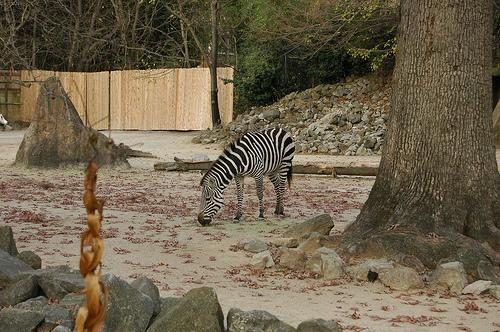Give a description of the plant leaf in the image. It is a brown dried plant leaf. Comment on the state of the trees in the photo. There are leafy trees, a tree with no leaves, and a large textured tree trunk. What is the zebra's interaction with the dried leaves in the image? The zebra is eating the dried leaves. How could one describe the reed in the scene? A light brown curled plant reed. What is the most noticeable feature of the zebra's tail and mane hair? The most noticeable feature is that they are both black in color. Point out an object that is fallen on the ground in the image. A tree log is fallen on the ground. Enumerate the number of rocks in the image and describe them. There are multiple rocks, including grey rocks in a pile, pointy triangular-shaped rock, and rocks in front of a tree. What is the predominant color of the fence panels in the image? The predominant color of the fence panels is brown. Describe the location of a slim tree in relation to the fence. The slim tree is positioned in front of the fence. Identify the main animal in the image and its action. The primary animal is a black and white zebra, which is eating something on the ground. Is the large rock in the image floating in the sky? The rocks are described as being on the ground or in piles, so mentioning a floating rock is misleading. Do you notice a river flowing through the image? There is no mention of a river or any water source in the image, making this instruction misleading. Are there any bright pink leaves scattered on the ground? The leaves described on the ground are either dried, dead, or red, so mentioning bright pink leaves is misleading. Are the fence panels painted bright green? The fence panels are described as brown and unfinished, so mentioning a bright green color is misleading. Is the zebra in the image blue and yellow? The zebra is described as black and white several times, making the mention of blue and yellow misleading. Can you see a group of giraffes in the background? There is no mention of giraffes at all in the image, making this instruction misleading. 